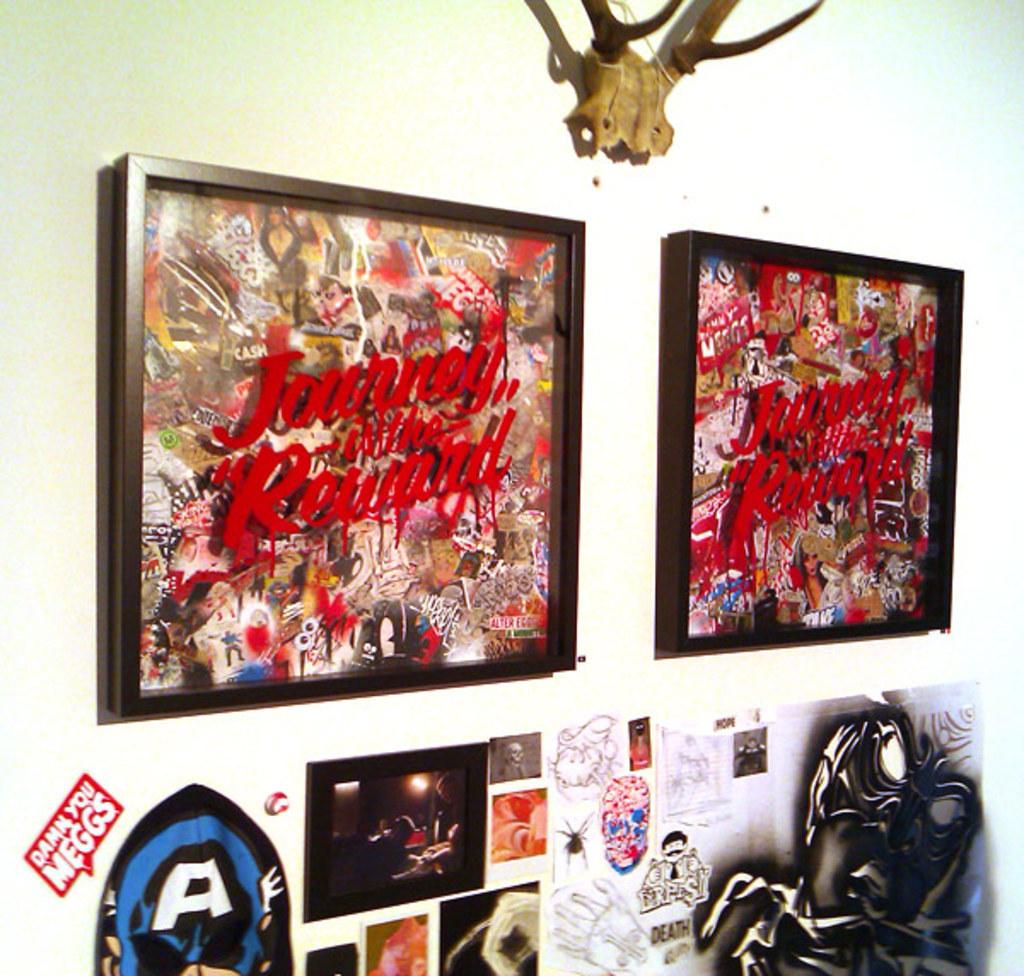What does the mirror say?
Provide a short and direct response. Journey is the reward. What letter is in the bottom left?
Provide a succinct answer. A. 